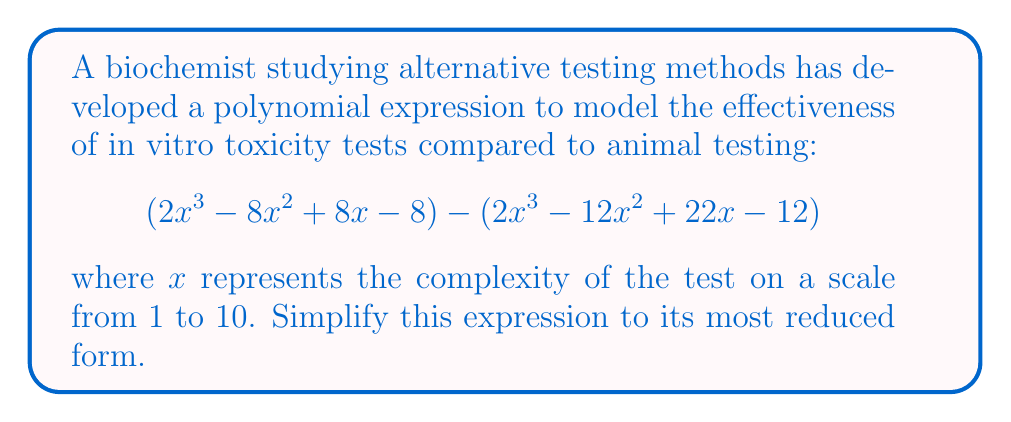What is the answer to this math problem? Let's approach this step-by-step:

1) First, we need to subtract the second polynomial from the first. We can do this by subtracting the coefficients of like terms:

   $$(2x^3 - 8x^2 + 8x - 8) - (2x^3 - 12x^2 + 22x - 12)$$

2) Subtracting the second polynomial is equivalent to adding its negative:

   $$(2x^3 - 8x^2 + 8x - 8) + (-2x^3 + 12x^2 - 22x + 12)$$

3) Now, we can combine like terms:

   For $x^3$ terms: $2x^3 + (-2x^3) = 0$
   For $x^2$ terms: $-8x^2 + 12x^2 = 4x^2$
   For $x$ terms: $8x + (-22x) = -14x$
   For constant terms: $-8 + 12 = 4$

4) Putting it all together:

   $$4x^2 - 14x + 4$$

5) This polynomial can be factored further. Let's check if it's a perfect square trinomial:

   $a^2 = 4x^2$, so $a = 2x$
   $c = 4$
   $2ac = 2(2x)(2) = 8x$

   The middle term should be $-8x$ for a perfect square, but it's $-14x$. So it's not a perfect square trinomial.

6) Let's try factoring by grouping:

   $$4x^2 - 14x + 4 = 2(2x^2 - 7x + 2)$$

7) The quadratic inside the parentheses can be factored:

   $$2(2x^2 - 7x + 2) = 2(2x - 1)(x - 2)$$

This is the most reduced form of the polynomial.
Answer: $$2(2x - 1)(x - 2)$$ 